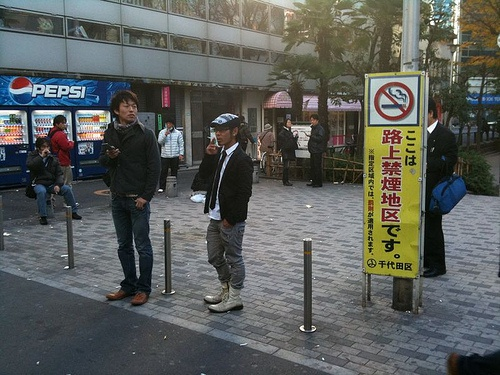Describe the objects in this image and their specific colors. I can see people in teal, black, gray, and maroon tones, people in teal, black, gray, darkgray, and maroon tones, people in teal, black, gray, white, and darkgray tones, people in teal, black, darkblue, gray, and blue tones, and people in teal, black, darkgray, gray, and lightblue tones in this image. 